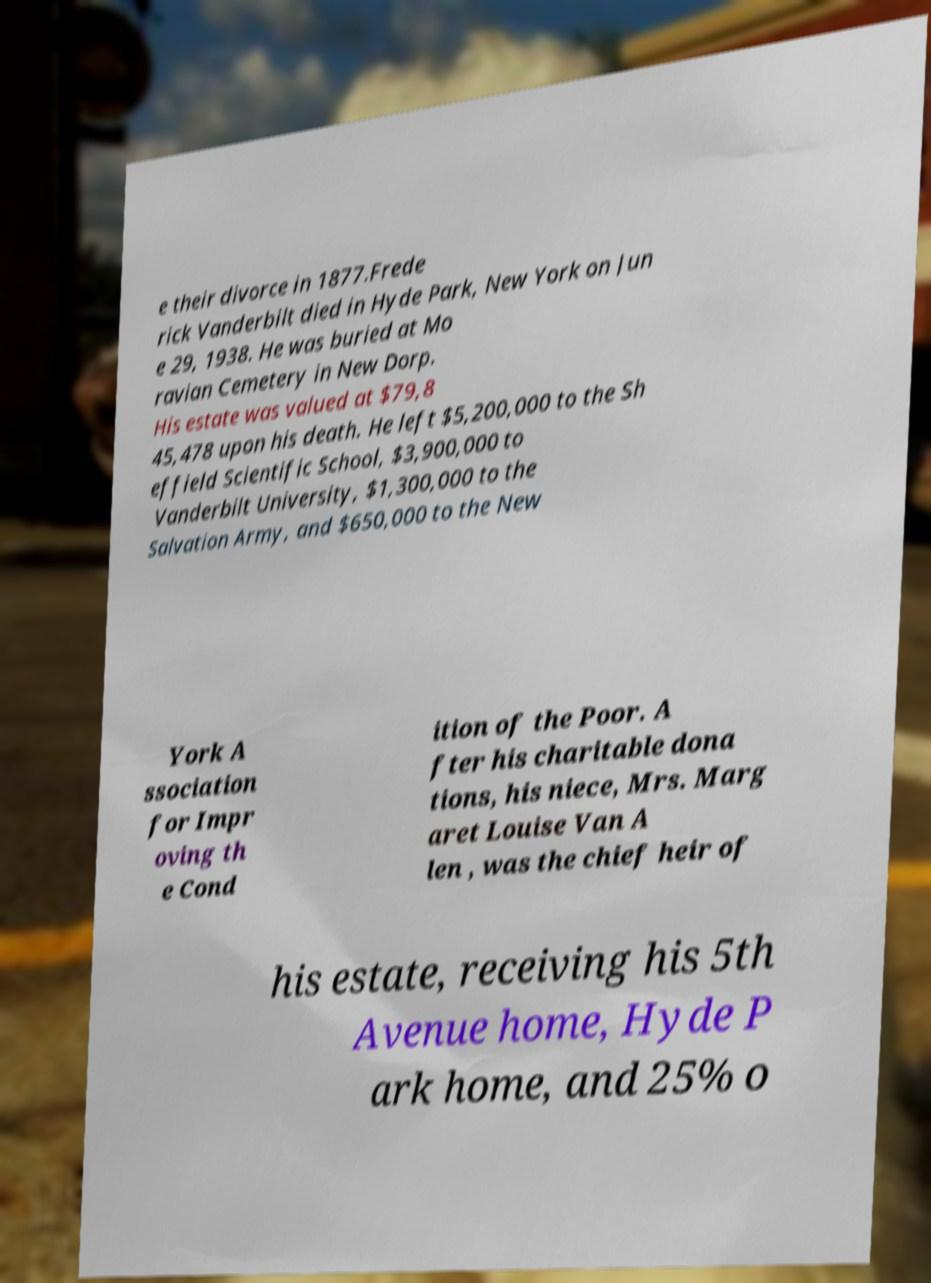What messages or text are displayed in this image? I need them in a readable, typed format. e their divorce in 1877.Frede rick Vanderbilt died in Hyde Park, New York on Jun e 29, 1938. He was buried at Mo ravian Cemetery in New Dorp. His estate was valued at $79,8 45,478 upon his death. He left $5,200,000 to the Sh effield Scientific School, $3,900,000 to Vanderbilt University, $1,300,000 to the Salvation Army, and $650,000 to the New York A ssociation for Impr oving th e Cond ition of the Poor. A fter his charitable dona tions, his niece, Mrs. Marg aret Louise Van A len , was the chief heir of his estate, receiving his 5th Avenue home, Hyde P ark home, and 25% o 